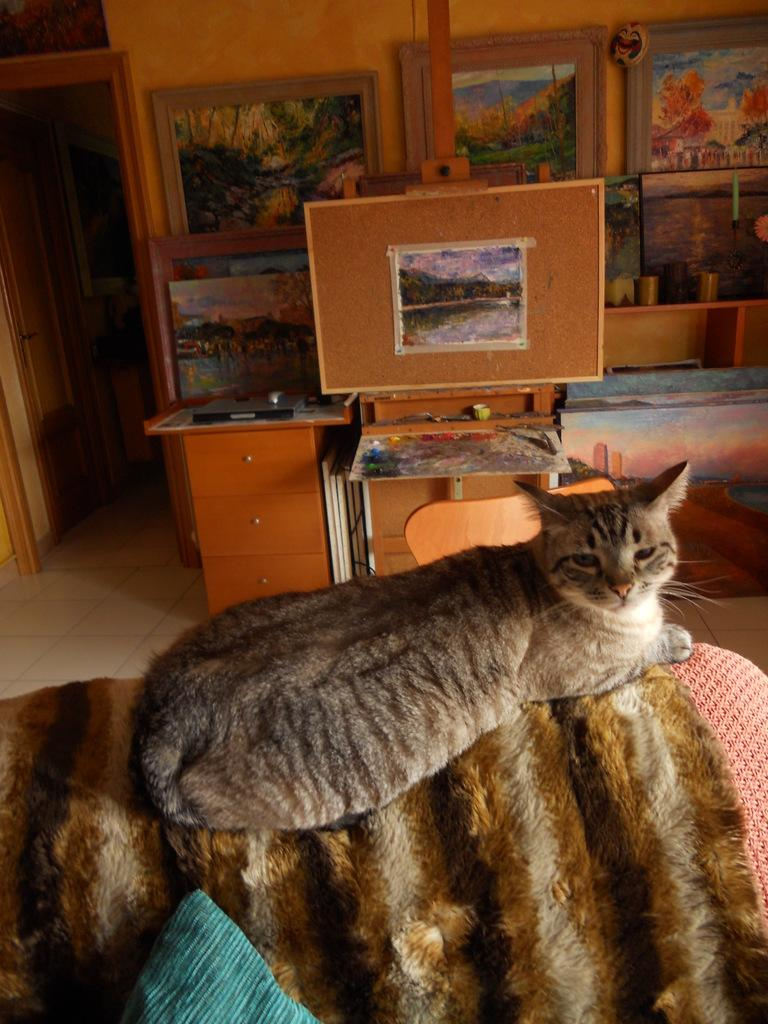What type of animal is in the image? There is a cat in the image. What is located behind the cat? There is a table behind the cat. What can be seen behind the table? There are many photo frames behind the table. Where is the door located in the image? The door is on the left side of the image. Is the cat wearing a crown in the image? No, the cat is not wearing a crown in the image. Can you see a person sitting at a lunchroom table in the image? No, there is no person or lunchroom table present in the image. 